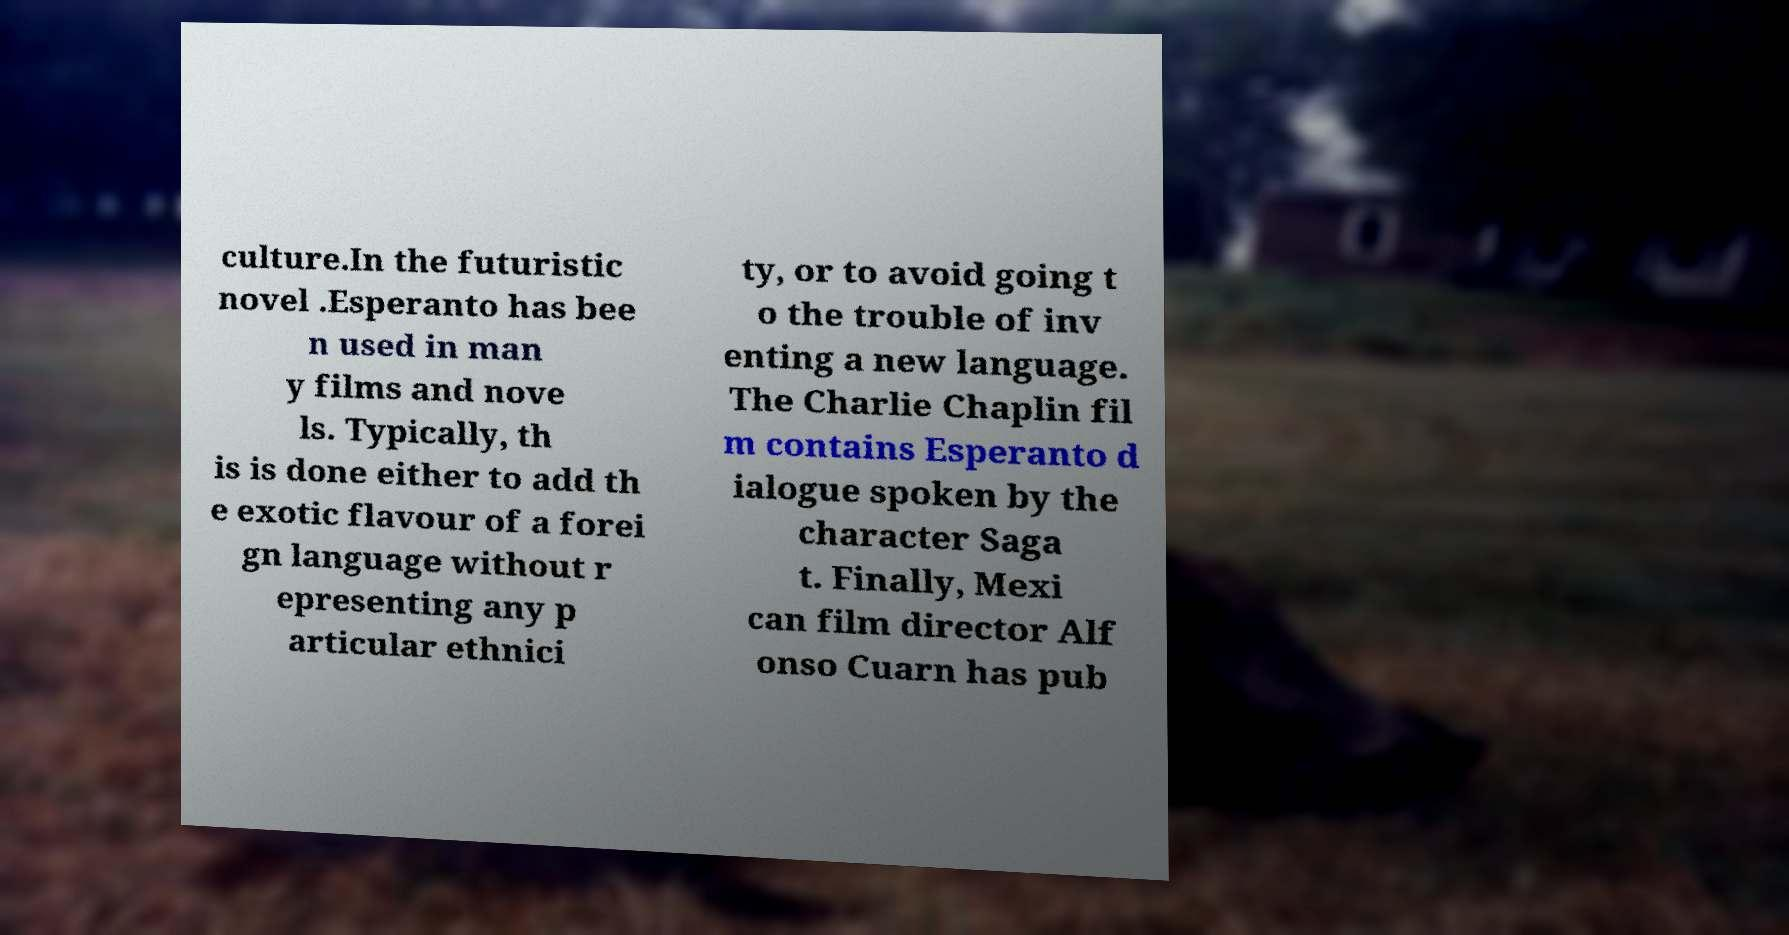For documentation purposes, I need the text within this image transcribed. Could you provide that? culture.In the futuristic novel .Esperanto has bee n used in man y films and nove ls. Typically, th is is done either to add th e exotic flavour of a forei gn language without r epresenting any p articular ethnici ty, or to avoid going t o the trouble of inv enting a new language. The Charlie Chaplin fil m contains Esperanto d ialogue spoken by the character Saga t. Finally, Mexi can film director Alf onso Cuarn has pub 